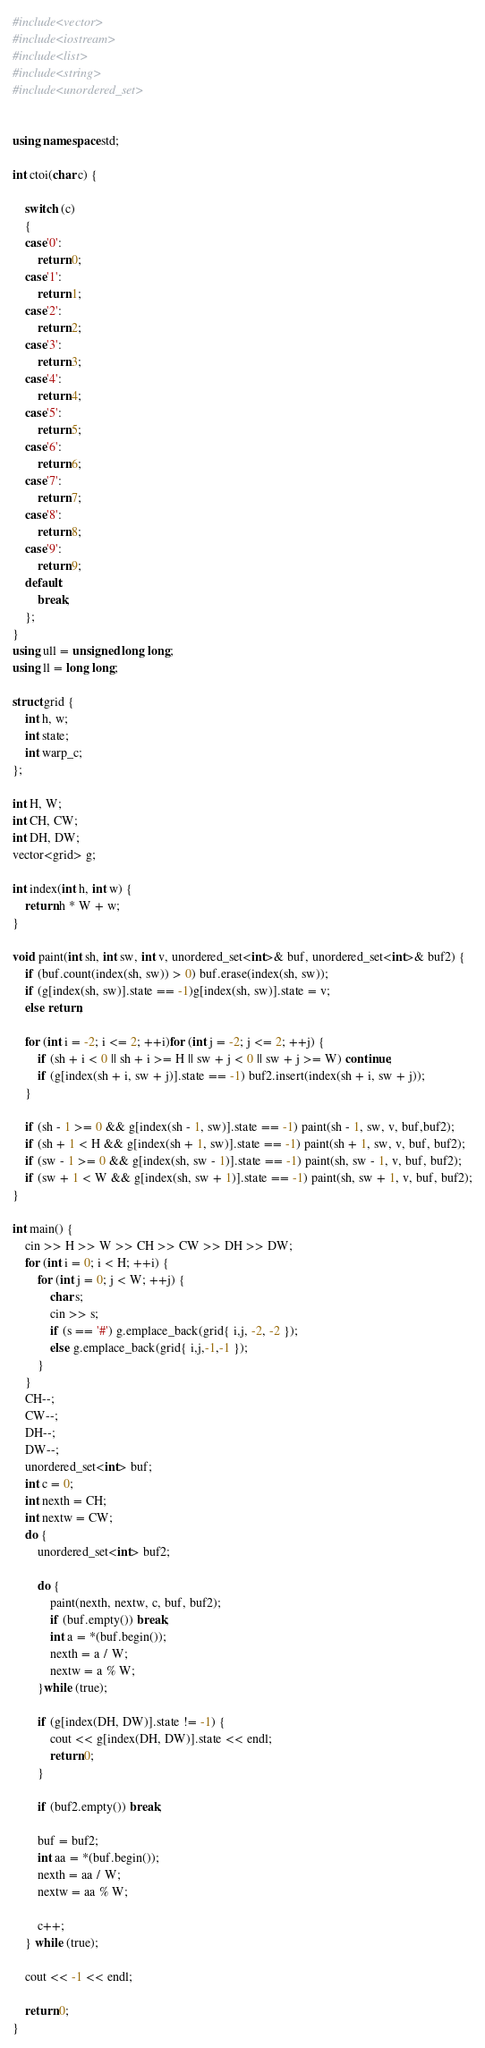<code> <loc_0><loc_0><loc_500><loc_500><_C++_>#include<vector>
#include<iostream>
#include<list>
#include<string>
#include<unordered_set>


using namespace std;

int ctoi(char c) {

	switch (c)
	{
	case'0':
		return 0;
	case'1':
		return 1;
	case'2':
		return 2;
	case'3':
		return 3;
	case'4':
		return 4;
	case'5':
		return 5;
	case'6':
		return 6;
	case'7':
		return 7;
	case'8':
		return 8;
	case'9':
		return 9;
	default:
		break;
	};
}
using ull = unsigned long long;
using ll = long long;

struct grid {
	int h, w;
	int state;
	int warp_c;
};

int H, W;
int CH, CW;
int DH, DW;
vector<grid> g;

int index(int h, int w) {
	return h * W + w;
}

void paint(int sh, int sw, int v, unordered_set<int>& buf, unordered_set<int>& buf2) {
	if (buf.count(index(sh, sw)) > 0) buf.erase(index(sh, sw));
	if (g[index(sh, sw)].state == -1)g[index(sh, sw)].state = v;
	else return;

	for (int i = -2; i <= 2; ++i)for (int j = -2; j <= 2; ++j) {
		if (sh + i < 0 || sh + i >= H || sw + j < 0 || sw + j >= W) continue;
		if (g[index(sh + i, sw + j)].state == -1) buf2.insert(index(sh + i, sw + j));
	}

	if (sh - 1 >= 0 && g[index(sh - 1, sw)].state == -1) paint(sh - 1, sw, v, buf,buf2);
	if (sh + 1 < H && g[index(sh + 1, sw)].state == -1) paint(sh + 1, sw, v, buf, buf2);
	if (sw - 1 >= 0 && g[index(sh, sw - 1)].state == -1) paint(sh, sw - 1, v, buf, buf2);
	if (sw + 1 < W && g[index(sh, sw + 1)].state == -1) paint(sh, sw + 1, v, buf, buf2);
}

int main() {
	cin >> H >> W >> CH >> CW >> DH >> DW;
	for (int i = 0; i < H; ++i) {
		for (int j = 0; j < W; ++j) {
			char s;
			cin >> s;
			if (s == '#') g.emplace_back(grid{ i,j, -2, -2 });
			else g.emplace_back(grid{ i,j,-1,-1 });
		}
	}
	CH--;
	CW--;
	DH--;
	DW--;
	unordered_set<int> buf;
	int c = 0;
	int nexth = CH;
	int nextw = CW;
	do {
		unordered_set<int> buf2;
		
		do {
			paint(nexth, nextw, c, buf, buf2);
			if (buf.empty()) break;
			int a = *(buf.begin());
			nexth = a / W;
			nextw = a % W;
		}while (true);

		if (g[index(DH, DW)].state != -1) {
			cout << g[index(DH, DW)].state << endl;
			return 0;
		}

		if (buf2.empty()) break;

		buf = buf2;
		int aa = *(buf.begin());
		nexth = aa / W;
		nextw = aa % W;

		c++;
	} while (true);

	cout << -1 << endl;

	return 0;
}
</code> 